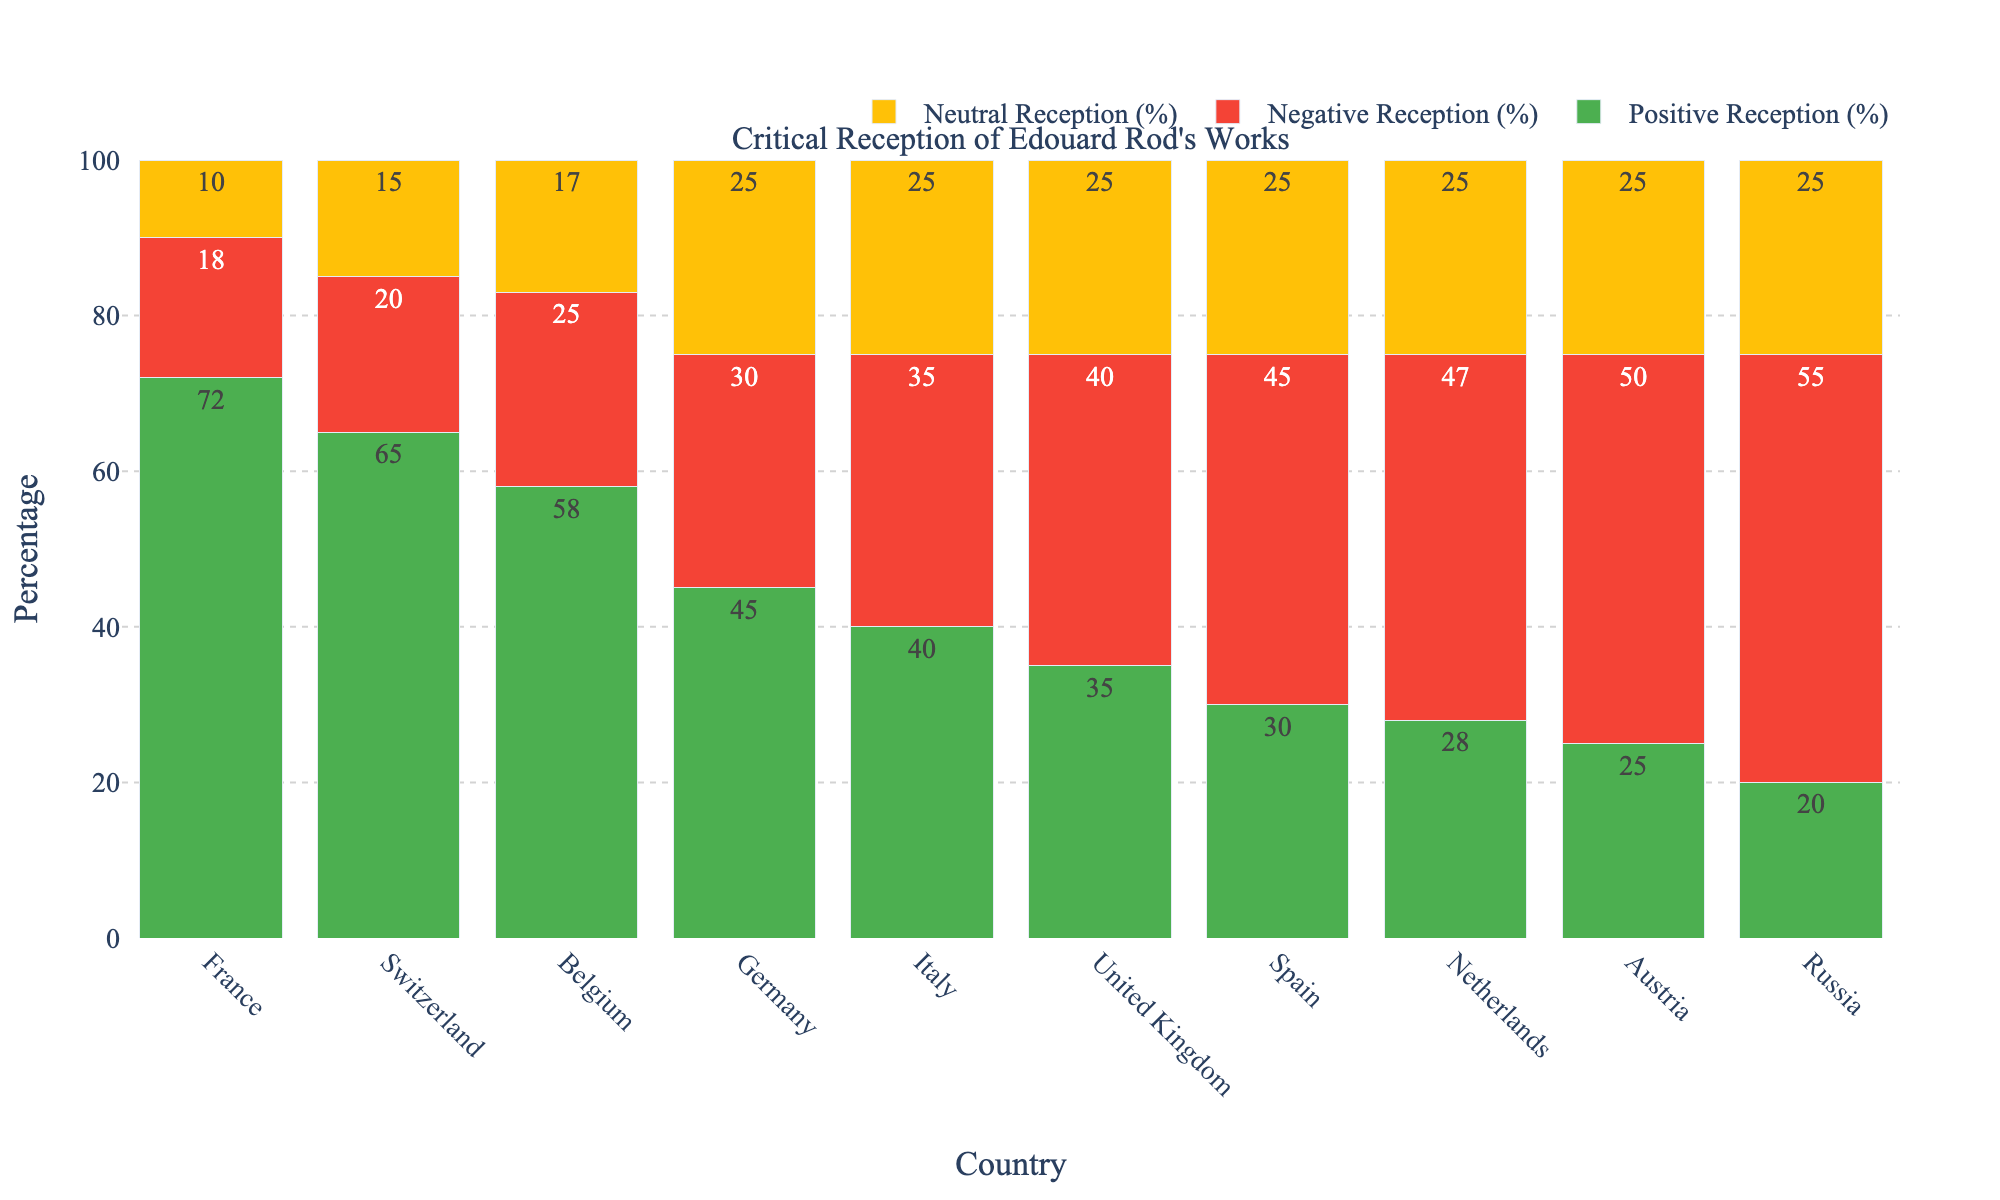Which country has the highest positive reception of Edouard Rod's works? The highest green bar represents the positive reception. The green bar for France is the tallest among all countries.
Answer: France Which country has the lowest neutral reception of Edouard Rod's works? The shortest orange bar represents the neutral reception. France has the shortest orange bar.
Answer: France What is the difference in the negative reception percentage between Russia and Switzerland? The negative reception for Russia is 55% and for Switzerland is 20%. The difference is 55 - 20.
Answer: 35% Which country has almost equal percentages of negative and neutral receptions? By observing the red and orange bars of similar height, United Kingdom shows nearly equal bar lengths for negative (40%) and neutral (25%).
Answer: United Kingdom Compare the positive reception percentages between Germany and Italy. Which country has a higher percentage, and by how much? Positive reception for Germany is 45% and for Italy is 40%. The difference is 45 - 40.
Answer: Germany, by 5% What's the compositional value of positive and neutral reception percentages for Spain? Positive reception for Spain is 30% and neutral reception is 25%. The sum is 30 + 25.
Answer: 55% What percentage of total reception types (positive, negative, neutral) do the positive receptions represent in Belgium? The sum of all reception types in Belgium is 58 + 25 + 17 = 100. Thus, the percentage is (58/100) * 100.
Answer: 58% Which country depicts a decreasing trend in positive receptions moving from left to right on the x-axis? Visually tracing the green bars from left to right, France shows the highest and the trend decreases moving rightwards to Russia.
Answer: Most countries What is the average percentage of neutral reception across all the given countries? Sum of neutral reception percentages: 10+15+17+25+25+25+25+25+25+25 = 217. Number of countries: 10. So, the average is 217/10.
Answer: 21.7% Which two countries have the most significant gap between positive and negative receptions? For the greatest difference, compare length differences of green (positive) and red (negative) bars. France, at 54%, and Russia, at -35%.
Answer: France and Russia 